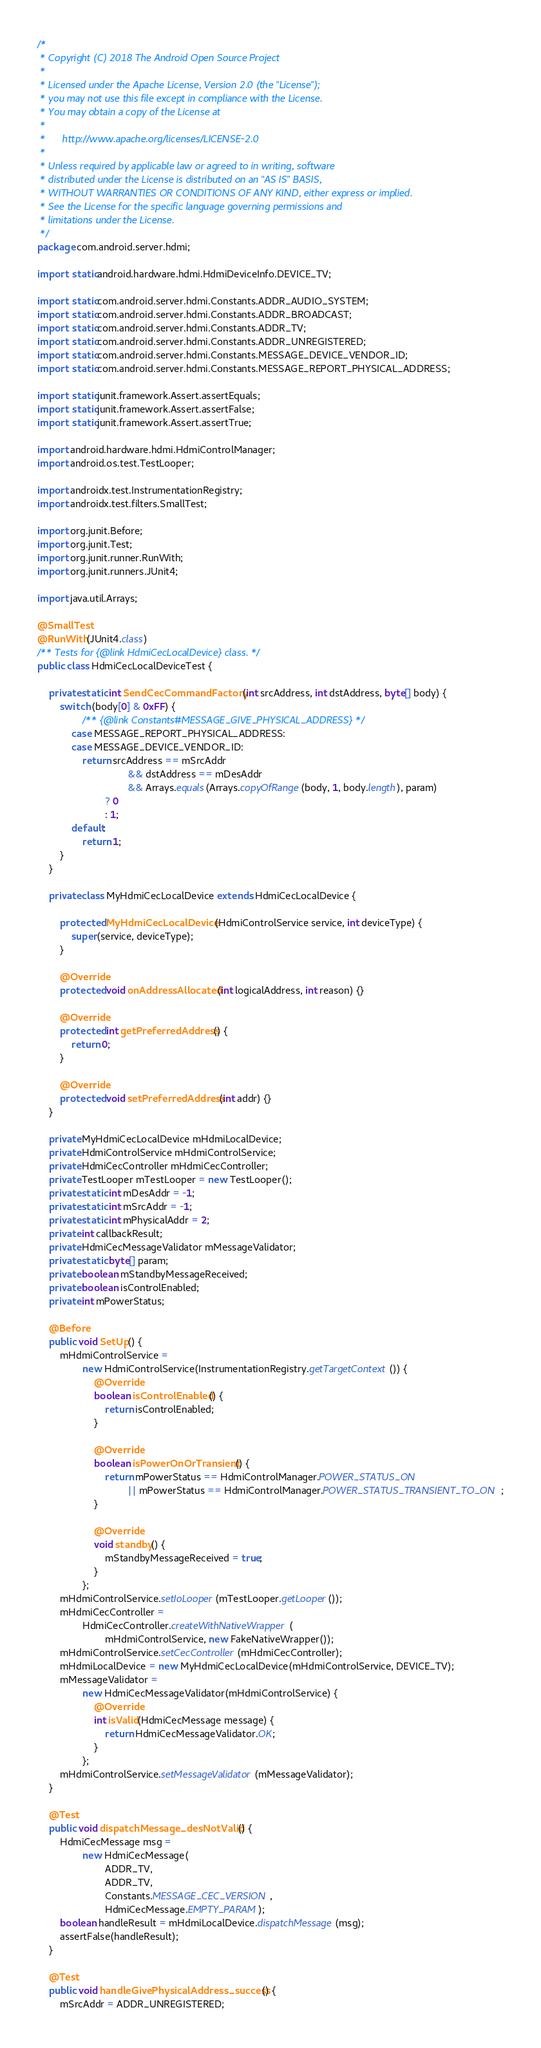Convert code to text. <code><loc_0><loc_0><loc_500><loc_500><_Java_>/*
 * Copyright (C) 2018 The Android Open Source Project
 *
 * Licensed under the Apache License, Version 2.0 (the "License");
 * you may not use this file except in compliance with the License.
 * You may obtain a copy of the License at
 *
 *      http://www.apache.org/licenses/LICENSE-2.0
 *
 * Unless required by applicable law or agreed to in writing, software
 * distributed under the License is distributed on an "AS IS" BASIS,
 * WITHOUT WARRANTIES OR CONDITIONS OF ANY KIND, either express or implied.
 * See the License for the specific language governing permissions and
 * limitations under the License.
 */
package com.android.server.hdmi;

import static android.hardware.hdmi.HdmiDeviceInfo.DEVICE_TV;

import static com.android.server.hdmi.Constants.ADDR_AUDIO_SYSTEM;
import static com.android.server.hdmi.Constants.ADDR_BROADCAST;
import static com.android.server.hdmi.Constants.ADDR_TV;
import static com.android.server.hdmi.Constants.ADDR_UNREGISTERED;
import static com.android.server.hdmi.Constants.MESSAGE_DEVICE_VENDOR_ID;
import static com.android.server.hdmi.Constants.MESSAGE_REPORT_PHYSICAL_ADDRESS;

import static junit.framework.Assert.assertEquals;
import static junit.framework.Assert.assertFalse;
import static junit.framework.Assert.assertTrue;

import android.hardware.hdmi.HdmiControlManager;
import android.os.test.TestLooper;

import androidx.test.InstrumentationRegistry;
import androidx.test.filters.SmallTest;

import org.junit.Before;
import org.junit.Test;
import org.junit.runner.RunWith;
import org.junit.runners.JUnit4;

import java.util.Arrays;

@SmallTest
@RunWith(JUnit4.class)
/** Tests for {@link HdmiCecLocalDevice} class. */
public class HdmiCecLocalDeviceTest {

    private static int SendCecCommandFactory(int srcAddress, int dstAddress, byte[] body) {
        switch (body[0] & 0xFF) {
                /** {@link Constants#MESSAGE_GIVE_PHYSICAL_ADDRESS} */
            case MESSAGE_REPORT_PHYSICAL_ADDRESS:
            case MESSAGE_DEVICE_VENDOR_ID:
                return srcAddress == mSrcAddr
                                && dstAddress == mDesAddr
                                && Arrays.equals(Arrays.copyOfRange(body, 1, body.length), param)
                        ? 0
                        : 1;
            default:
                return 1;
        }
    }

    private class MyHdmiCecLocalDevice extends HdmiCecLocalDevice {

        protected MyHdmiCecLocalDevice(HdmiControlService service, int deviceType) {
            super(service, deviceType);
        }

        @Override
        protected void onAddressAllocated(int logicalAddress, int reason) {}

        @Override
        protected int getPreferredAddress() {
            return 0;
        }

        @Override
        protected void setPreferredAddress(int addr) {}
    }

    private MyHdmiCecLocalDevice mHdmiLocalDevice;
    private HdmiControlService mHdmiControlService;
    private HdmiCecController mHdmiCecController;
    private TestLooper mTestLooper = new TestLooper();
    private static int mDesAddr = -1;
    private static int mSrcAddr = -1;
    private static int mPhysicalAddr = 2;
    private int callbackResult;
    private HdmiCecMessageValidator mMessageValidator;
    private static byte[] param;
    private boolean mStandbyMessageReceived;
    private boolean isControlEnabled;
    private int mPowerStatus;

    @Before
    public void SetUp() {
        mHdmiControlService =
                new HdmiControlService(InstrumentationRegistry.getTargetContext()) {
                    @Override
                    boolean isControlEnabled() {
                        return isControlEnabled;
                    }

                    @Override
                    boolean isPowerOnOrTransient() {
                        return mPowerStatus == HdmiControlManager.POWER_STATUS_ON
                                || mPowerStatus == HdmiControlManager.POWER_STATUS_TRANSIENT_TO_ON;
                    }

                    @Override
                    void standby() {
                        mStandbyMessageReceived = true;
                    }
                };
        mHdmiControlService.setIoLooper(mTestLooper.getLooper());
        mHdmiCecController =
                HdmiCecController.createWithNativeWrapper(
                        mHdmiControlService, new FakeNativeWrapper());
        mHdmiControlService.setCecController(mHdmiCecController);
        mHdmiLocalDevice = new MyHdmiCecLocalDevice(mHdmiControlService, DEVICE_TV);
        mMessageValidator =
                new HdmiCecMessageValidator(mHdmiControlService) {
                    @Override
                    int isValid(HdmiCecMessage message) {
                        return HdmiCecMessageValidator.OK;
                    }
                };
        mHdmiControlService.setMessageValidator(mMessageValidator);
    }

    @Test
    public void dispatchMessage_desNotValid() {
        HdmiCecMessage msg =
                new HdmiCecMessage(
                        ADDR_TV,
                        ADDR_TV,
                        Constants.MESSAGE_CEC_VERSION,
                        HdmiCecMessage.EMPTY_PARAM);
        boolean handleResult = mHdmiLocalDevice.dispatchMessage(msg);
        assertFalse(handleResult);
    }

    @Test
    public void handleGivePhysicalAddress_success() {
        mSrcAddr = ADDR_UNREGISTERED;</code> 